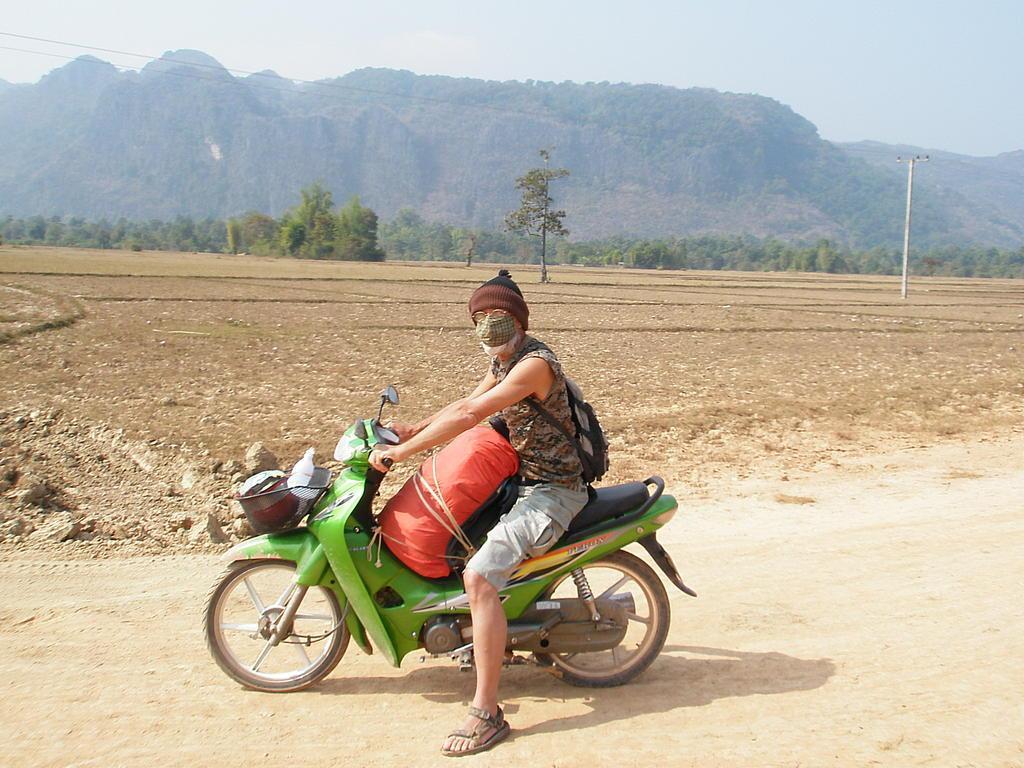Could you give a brief overview of what you see in this image? There is a person sitting on a green bike and there is a luggage in front of him and there are trees and mountain beside him. 